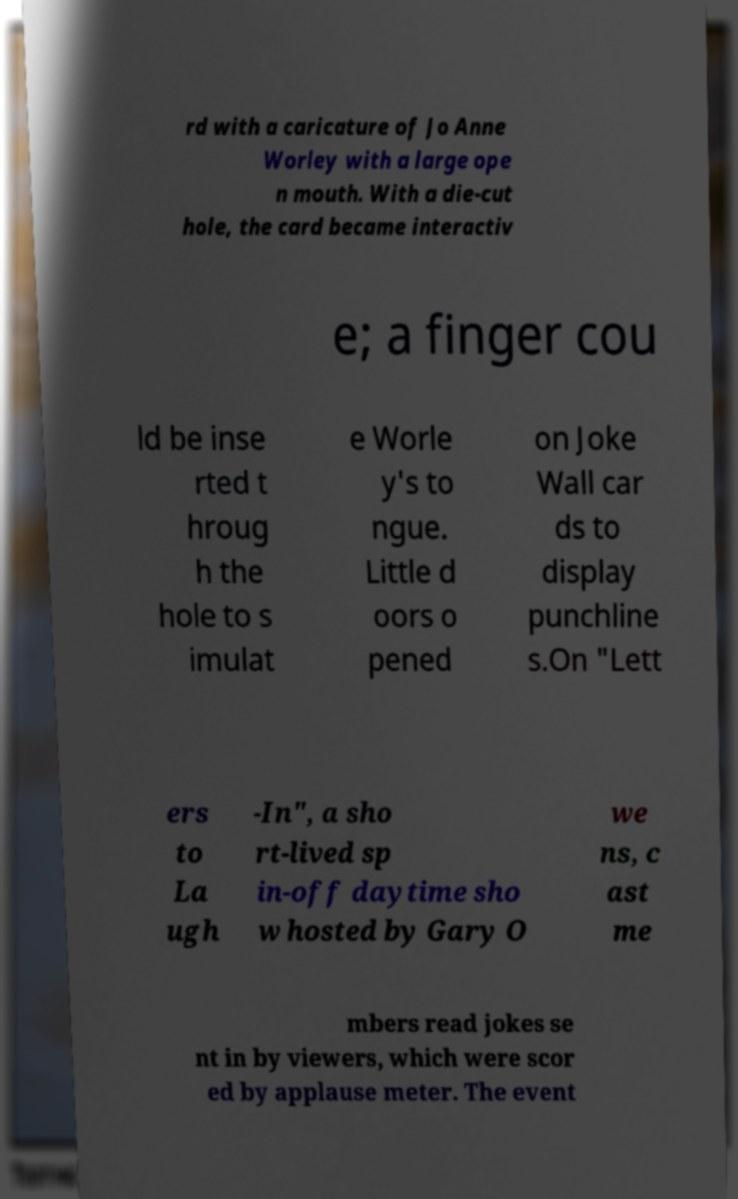Could you assist in decoding the text presented in this image and type it out clearly? rd with a caricature of Jo Anne Worley with a large ope n mouth. With a die-cut hole, the card became interactiv e; a finger cou ld be inse rted t hroug h the hole to s imulat e Worle y's to ngue. Little d oors o pened on Joke Wall car ds to display punchline s.On "Lett ers to La ugh -In", a sho rt-lived sp in-off daytime sho w hosted by Gary O we ns, c ast me mbers read jokes se nt in by viewers, which were scor ed by applause meter. The event 